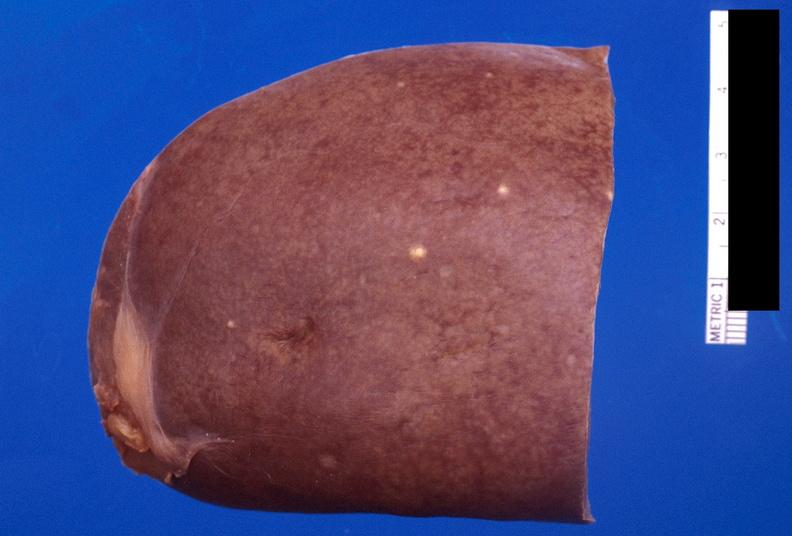does this image show spleen, fungal abscesses, candida?
Answer the question using a single word or phrase. Yes 